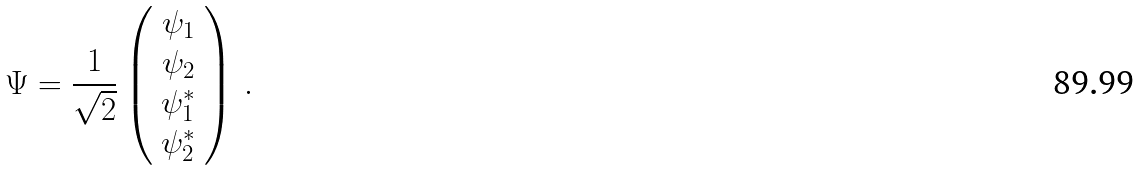<formula> <loc_0><loc_0><loc_500><loc_500>\Psi = \frac { 1 } { \sqrt { 2 } } \left ( \begin{array} { c } \psi _ { 1 } \\ \psi _ { 2 } \\ \psi _ { 1 } ^ { * } \\ \psi _ { 2 } ^ { * } \end{array} \right ) \, .</formula> 